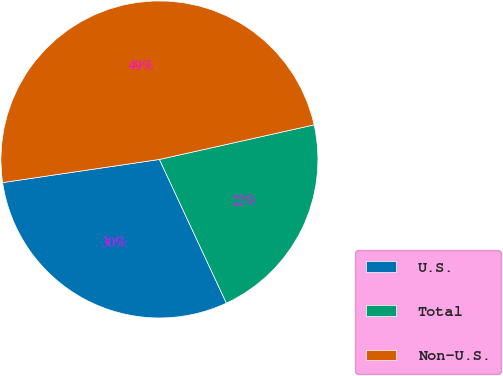Convert chart to OTSL. <chart><loc_0><loc_0><loc_500><loc_500><pie_chart><fcel>U.S.<fcel>Total<fcel>Non-U.S.<nl><fcel>29.61%<fcel>21.56%<fcel>48.83%<nl></chart> 